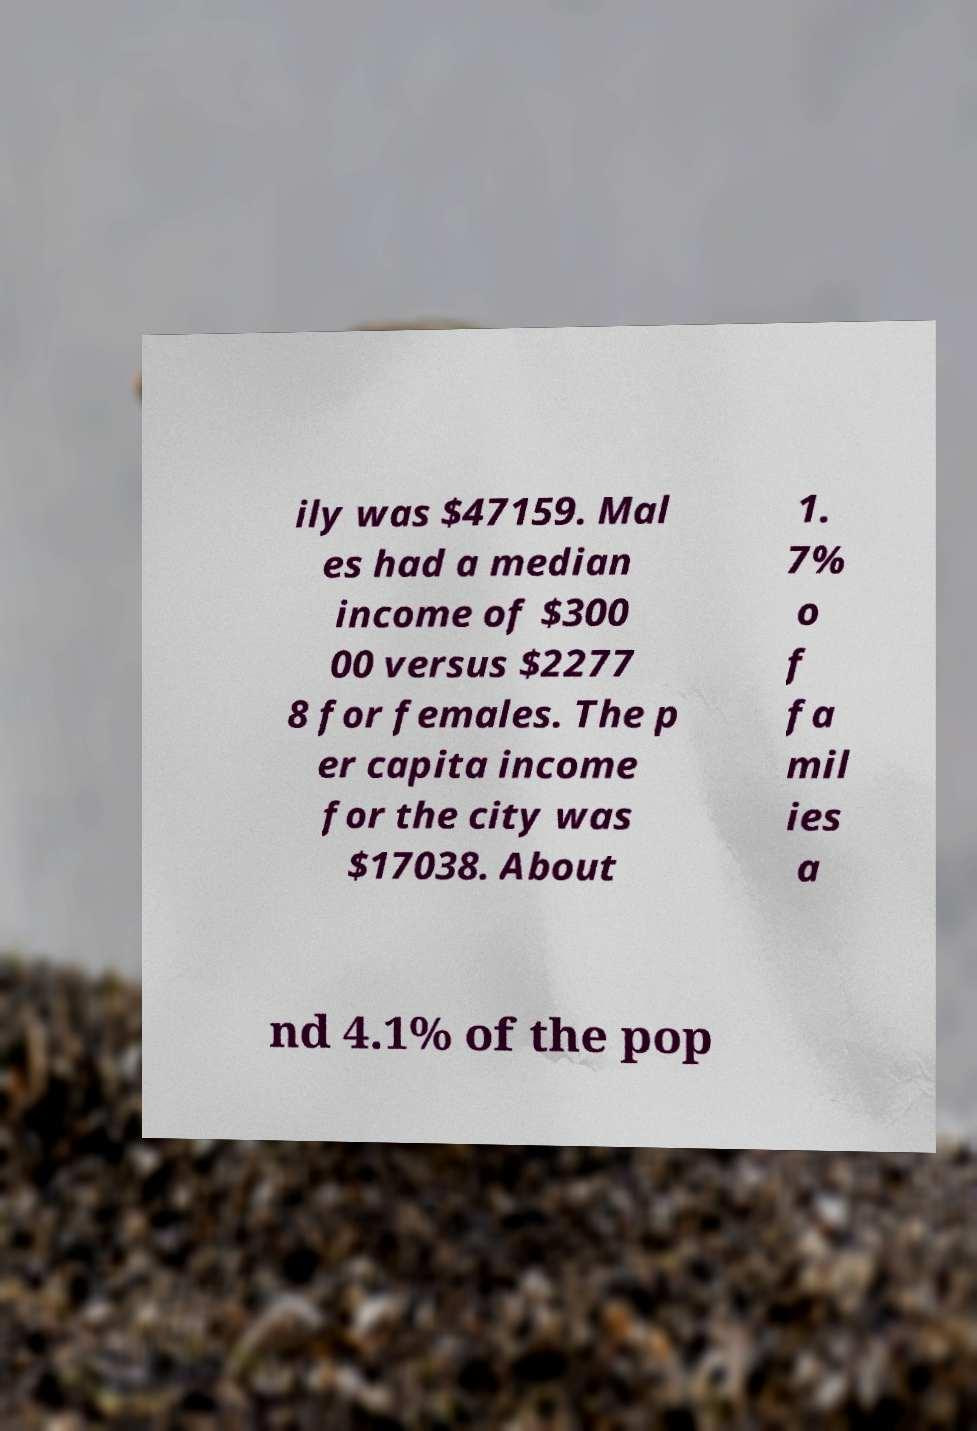Please identify and transcribe the text found in this image. ily was $47159. Mal es had a median income of $300 00 versus $2277 8 for females. The p er capita income for the city was $17038. About 1. 7% o f fa mil ies a nd 4.1% of the pop 